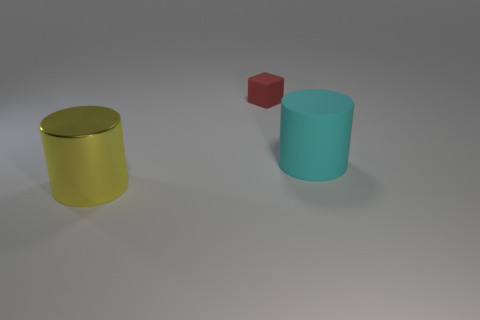What is the big cyan thing made of?
Your response must be concise. Rubber. What is the yellow cylinder that is to the left of the small rubber cube made of?
Make the answer very short. Metal. Is there any other thing that is the same color as the big metallic object?
Ensure brevity in your answer.  No. What is the size of the cyan cylinder that is the same material as the tiny red cube?
Your answer should be very brief. Large. What number of tiny things are either purple matte cubes or cubes?
Offer a terse response. 1. How big is the rubber thing that is left of the big cylinder that is right of the small red object that is behind the big yellow metal object?
Provide a succinct answer. Small. How many cyan rubber cylinders are the same size as the shiny thing?
Give a very brief answer. 1. How many objects are red blocks or cylinders behind the yellow thing?
Your answer should be compact. 2. There is a small red matte thing; what shape is it?
Keep it short and to the point. Cube. Do the small thing and the metal object have the same color?
Your response must be concise. No. 